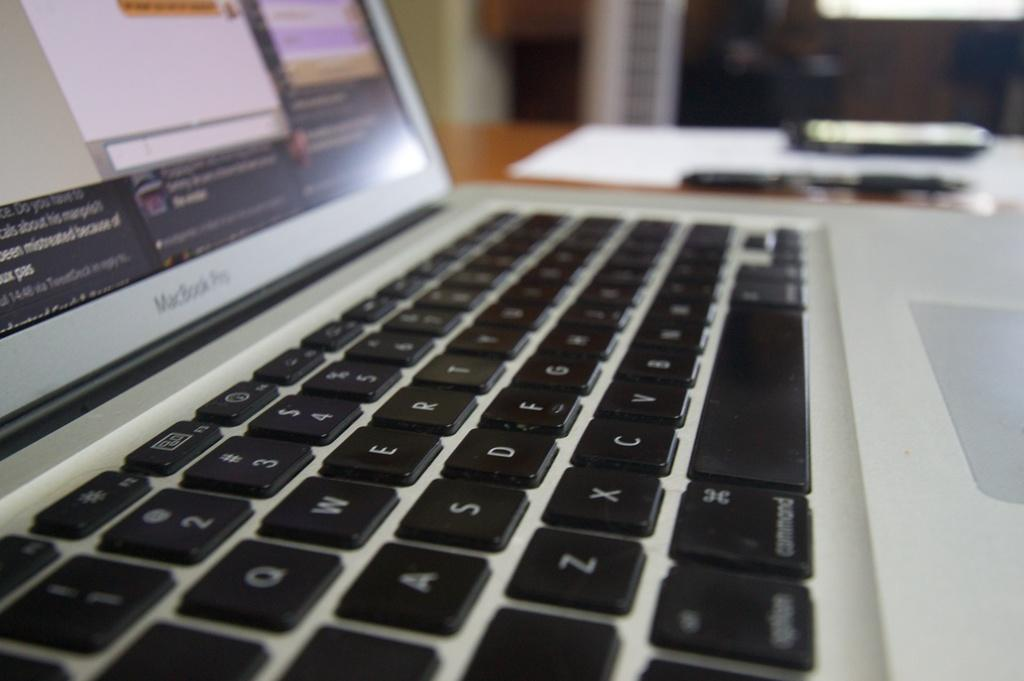What electronic device is visible in the image? There is a laptop in the image. Where is the laptop located? The laptop is on a table. What else can be seen on the table? There are other objects on the table. What can be seen in the background of the image? There are other objects visible in the background of the image. What type of peace symbol can be seen on the laptop in the image? There is no peace symbol visible on the laptop in the image. How many stars are present on the laptop in the image? There are no stars visible on the laptop in the image. 